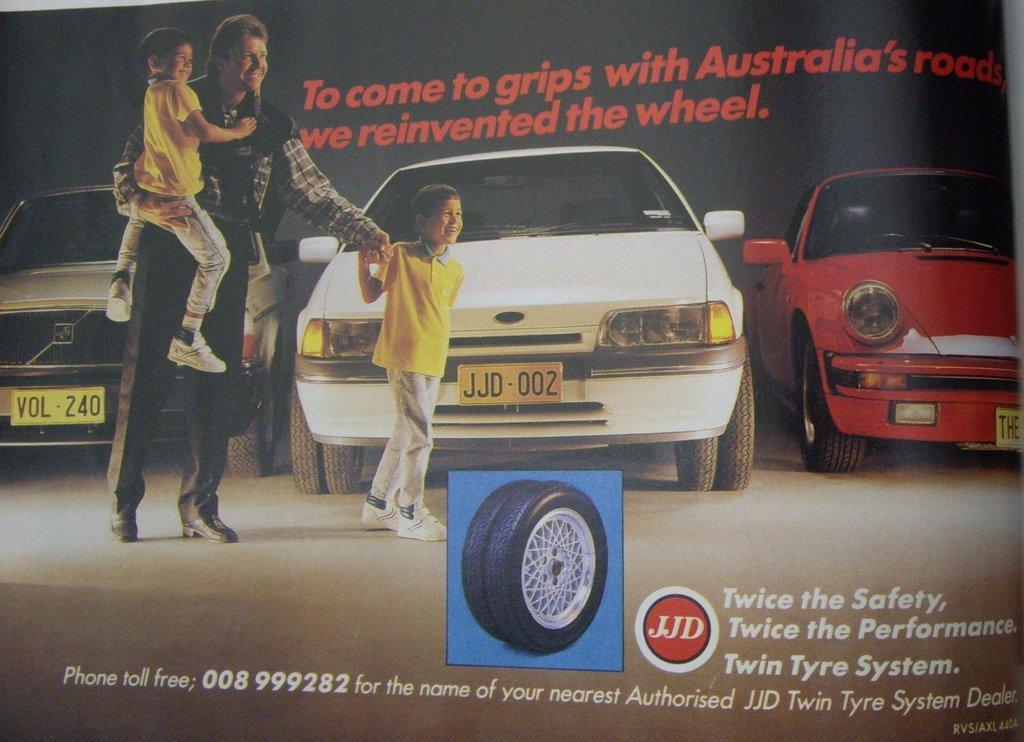Can you describe this image briefly? This picture seems to be an edited image. In the center we can see the tires. On the left there is a person holding a kid and walking on the ground and there is a kid wearing a yellow color t-shirt, smiling and walking on the ground. In the background we can see the group of cars parked on the ground and we can see the text on the image. 